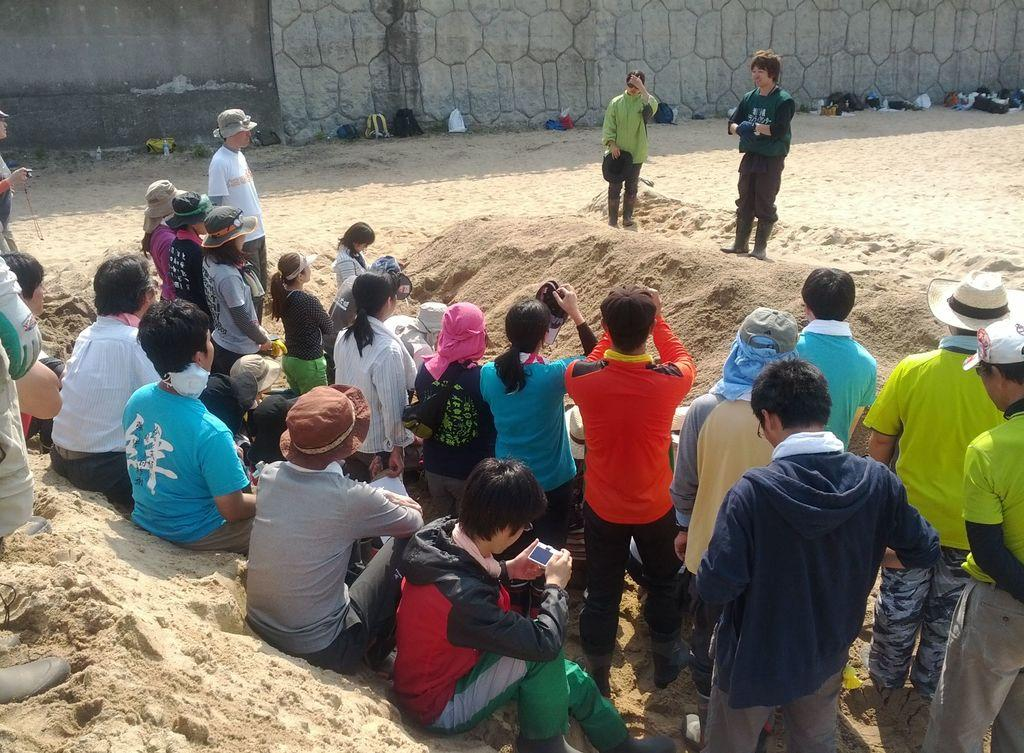Who or what can be seen in the image? There are people in the image. What type of surface is visible in the image? There is sand in the image. What can be seen in the background of the image? There is a wall in the background of the image. What items are placed in front of the wall? There are bags and other objects in front of the wall. What type of shoes can be seen in the image? There is no mention of shoes in the provided facts, so we cannot determine if any shoes are present in the image. 